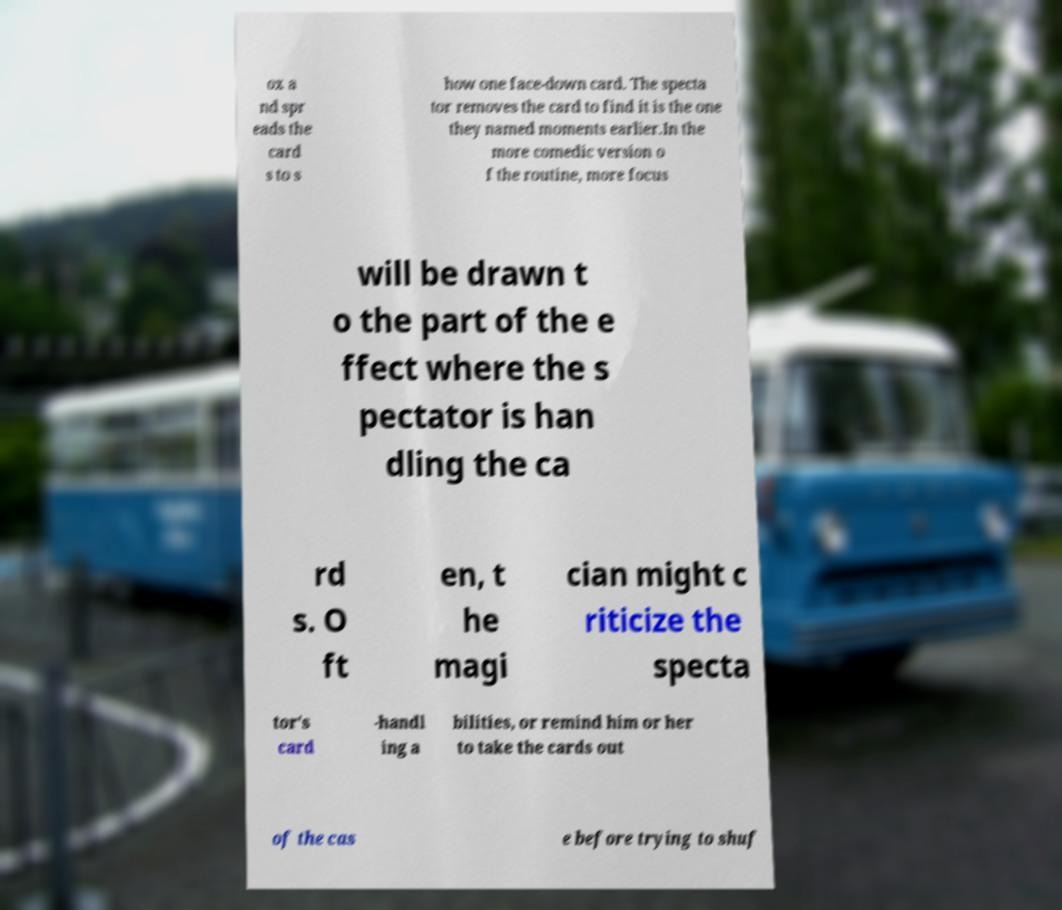I need the written content from this picture converted into text. Can you do that? ox a nd spr eads the card s to s how one face-down card. The specta tor removes the card to find it is the one they named moments earlier.In the more comedic version o f the routine, more focus will be drawn t o the part of the e ffect where the s pectator is han dling the ca rd s. O ft en, t he magi cian might c riticize the specta tor's card -handl ing a bilities, or remind him or her to take the cards out of the cas e before trying to shuf 